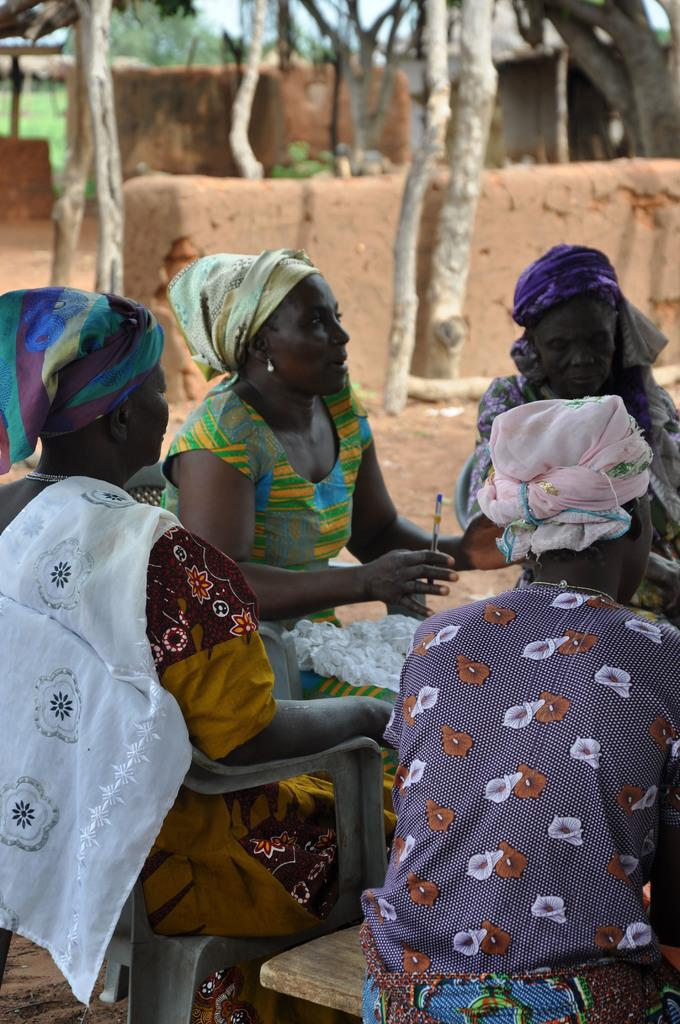Where was the image taken? The image was clicked outside. What are the people in the image doing? The people are sitting in the middle of the image. What can be seen in the background of the image? There are trees visible at the top of the image. What type of jeans are the trees wearing in the image? There are no jeans present in the image, as the trees are not wearing any clothing. 